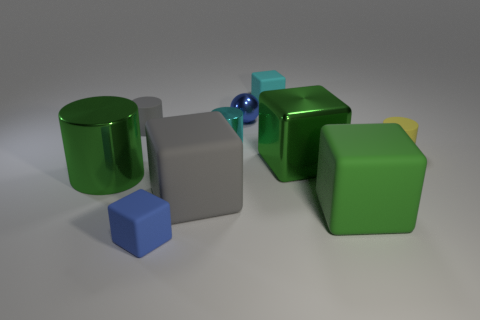How many tiny gray cylinders are the same material as the blue block?
Give a very brief answer. 1. What number of things are either tiny cyan things or large green objects that are left of the small gray matte thing?
Offer a terse response. 3. Is the material of the green object to the left of the small blue matte block the same as the gray cylinder?
Provide a short and direct response. No. There is a metal cylinder that is the same size as the gray matte block; what color is it?
Offer a terse response. Green. Is there a large green metal thing that has the same shape as the small gray object?
Your answer should be very brief. Yes. There is a small rubber thing that is behind the tiny rubber cylinder that is left of the matte cylinder on the right side of the gray rubber cylinder; what color is it?
Your answer should be compact. Cyan. What number of metallic objects are gray cubes or big green cubes?
Your answer should be compact. 1. Are there more big rubber blocks in front of the gray block than large green metal things that are in front of the big green matte object?
Offer a very short reply. Yes. How many other objects are there of the same size as the yellow cylinder?
Offer a terse response. 5. There is a shiny thing that is on the left side of the blue thing to the left of the large gray matte block; what size is it?
Offer a terse response. Large. 